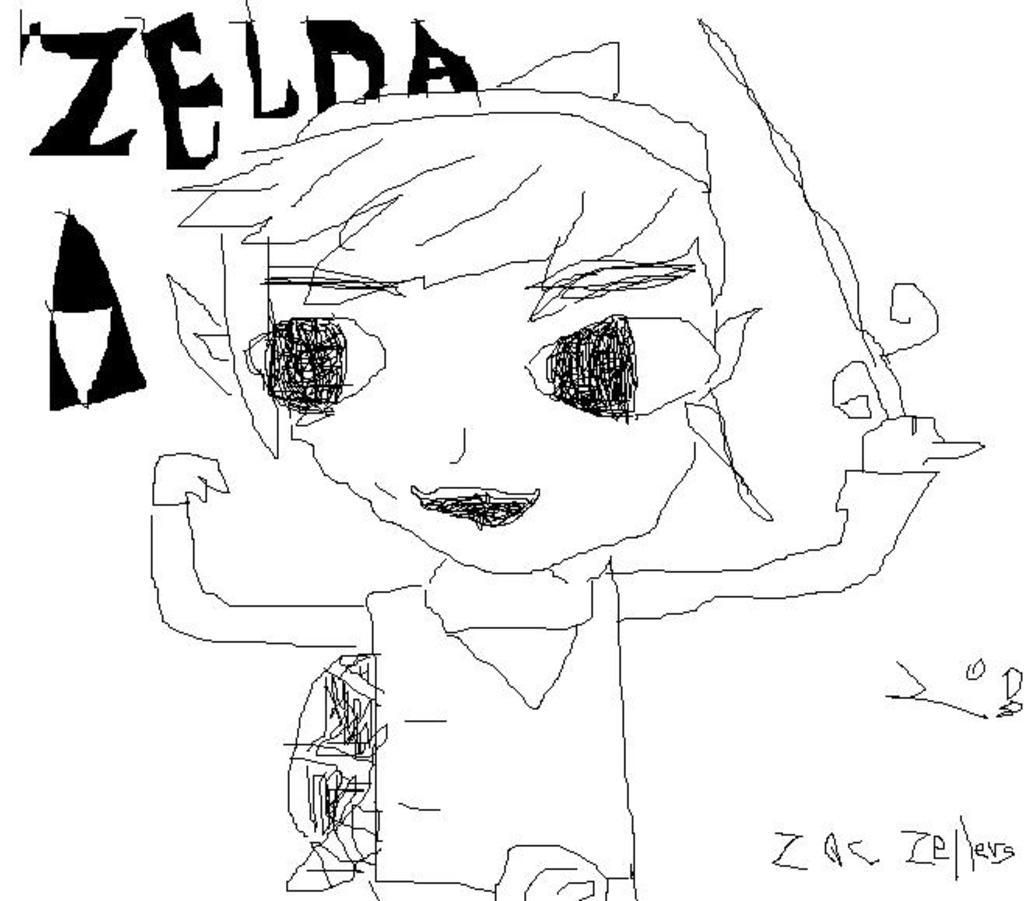What is depicted in the drawing in the image? There is a drawing of a boy in the image. What is the boy holding in his left hand? The boy is holding an object in his left hand. What structure can be seen in the image? There is a tent in the image. What can be found in addition to the drawing in the image? There is text or writing in the image. What color is the backdrop of the image? The backdrop of the image is a white surface. How many ants are crawling on the boy's drawing in the image? There are no ants present in the image; it features a drawing of a boy holding an object and a tent, along with text or writing on a white surface. What type of maid is attending to the boy in the image? There is no maid present in the image; it only features a drawing of a boy, a tent, text or writing, and a white backdrop. 